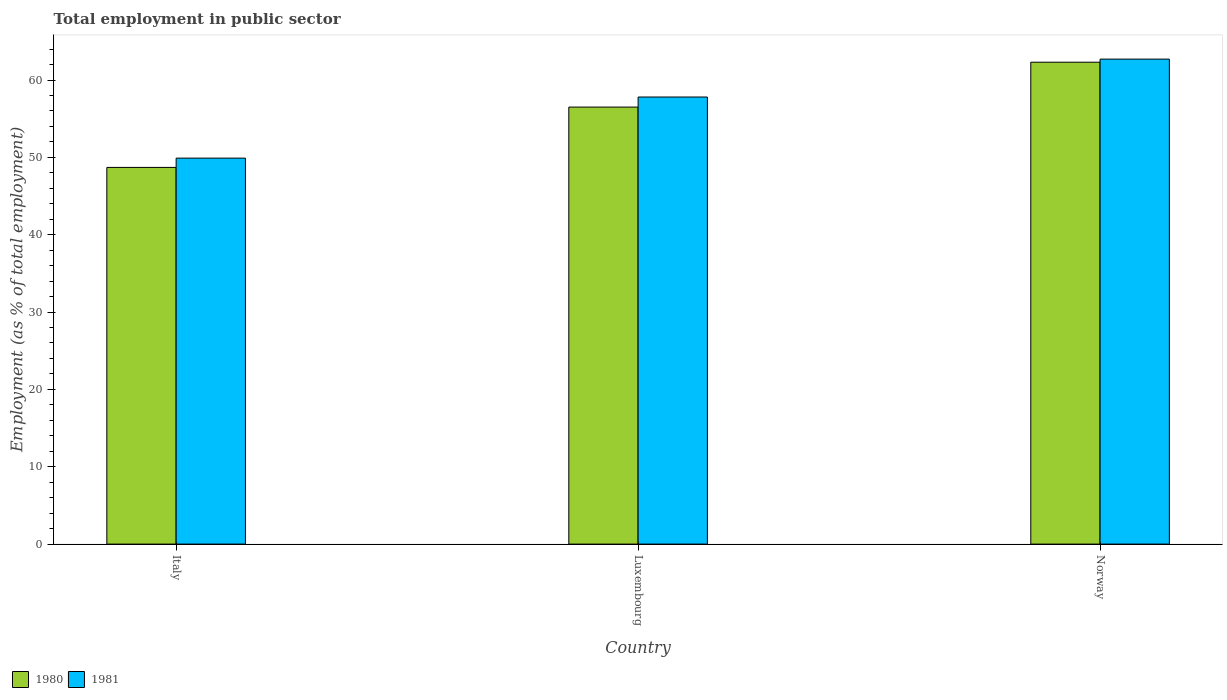How many different coloured bars are there?
Your answer should be compact. 2. How many groups of bars are there?
Ensure brevity in your answer.  3. How many bars are there on the 2nd tick from the left?
Offer a terse response. 2. In how many cases, is the number of bars for a given country not equal to the number of legend labels?
Give a very brief answer. 0. What is the employment in public sector in 1980 in Norway?
Ensure brevity in your answer.  62.3. Across all countries, what is the maximum employment in public sector in 1980?
Your response must be concise. 62.3. Across all countries, what is the minimum employment in public sector in 1981?
Your response must be concise. 49.9. In which country was the employment in public sector in 1980 maximum?
Provide a short and direct response. Norway. What is the total employment in public sector in 1981 in the graph?
Your answer should be compact. 170.4. What is the difference between the employment in public sector in 1981 in Italy and that in Luxembourg?
Give a very brief answer. -7.9. What is the average employment in public sector in 1980 per country?
Your answer should be compact. 55.83. What is the difference between the employment in public sector of/in 1981 and employment in public sector of/in 1980 in Norway?
Ensure brevity in your answer.  0.4. What is the ratio of the employment in public sector in 1980 in Italy to that in Luxembourg?
Give a very brief answer. 0.86. Is the employment in public sector in 1980 in Italy less than that in Luxembourg?
Ensure brevity in your answer.  Yes. Is the difference between the employment in public sector in 1981 in Italy and Norway greater than the difference between the employment in public sector in 1980 in Italy and Norway?
Offer a terse response. Yes. What is the difference between the highest and the second highest employment in public sector in 1980?
Make the answer very short. 7.8. What is the difference between the highest and the lowest employment in public sector in 1980?
Provide a short and direct response. 13.6. Is the sum of the employment in public sector in 1980 in Luxembourg and Norway greater than the maximum employment in public sector in 1981 across all countries?
Provide a succinct answer. Yes. What does the 2nd bar from the left in Italy represents?
Provide a succinct answer. 1981. What does the 2nd bar from the right in Luxembourg represents?
Offer a terse response. 1980. What is the difference between two consecutive major ticks on the Y-axis?
Keep it short and to the point. 10. Does the graph contain grids?
Keep it short and to the point. No. How are the legend labels stacked?
Offer a very short reply. Horizontal. What is the title of the graph?
Your response must be concise. Total employment in public sector. What is the label or title of the X-axis?
Provide a short and direct response. Country. What is the label or title of the Y-axis?
Offer a terse response. Employment (as % of total employment). What is the Employment (as % of total employment) of 1980 in Italy?
Keep it short and to the point. 48.7. What is the Employment (as % of total employment) in 1981 in Italy?
Offer a terse response. 49.9. What is the Employment (as % of total employment) in 1980 in Luxembourg?
Offer a terse response. 56.5. What is the Employment (as % of total employment) of 1981 in Luxembourg?
Your answer should be very brief. 57.8. What is the Employment (as % of total employment) in 1980 in Norway?
Provide a short and direct response. 62.3. What is the Employment (as % of total employment) of 1981 in Norway?
Your response must be concise. 62.7. Across all countries, what is the maximum Employment (as % of total employment) in 1980?
Your response must be concise. 62.3. Across all countries, what is the maximum Employment (as % of total employment) in 1981?
Your response must be concise. 62.7. Across all countries, what is the minimum Employment (as % of total employment) of 1980?
Provide a succinct answer. 48.7. Across all countries, what is the minimum Employment (as % of total employment) of 1981?
Give a very brief answer. 49.9. What is the total Employment (as % of total employment) in 1980 in the graph?
Your answer should be very brief. 167.5. What is the total Employment (as % of total employment) in 1981 in the graph?
Offer a terse response. 170.4. What is the difference between the Employment (as % of total employment) in 1980 in Italy and that in Luxembourg?
Give a very brief answer. -7.8. What is the difference between the Employment (as % of total employment) of 1981 in Italy and that in Luxembourg?
Your answer should be compact. -7.9. What is the difference between the Employment (as % of total employment) of 1980 in Luxembourg and that in Norway?
Offer a very short reply. -5.8. What is the difference between the Employment (as % of total employment) of 1981 in Luxembourg and that in Norway?
Offer a very short reply. -4.9. What is the difference between the Employment (as % of total employment) in 1980 in Italy and the Employment (as % of total employment) in 1981 in Luxembourg?
Provide a short and direct response. -9.1. What is the difference between the Employment (as % of total employment) of 1980 in Luxembourg and the Employment (as % of total employment) of 1981 in Norway?
Your answer should be compact. -6.2. What is the average Employment (as % of total employment) of 1980 per country?
Keep it short and to the point. 55.83. What is the average Employment (as % of total employment) in 1981 per country?
Provide a succinct answer. 56.8. What is the difference between the Employment (as % of total employment) in 1980 and Employment (as % of total employment) in 1981 in Luxembourg?
Keep it short and to the point. -1.3. What is the difference between the Employment (as % of total employment) of 1980 and Employment (as % of total employment) of 1981 in Norway?
Give a very brief answer. -0.4. What is the ratio of the Employment (as % of total employment) of 1980 in Italy to that in Luxembourg?
Keep it short and to the point. 0.86. What is the ratio of the Employment (as % of total employment) of 1981 in Italy to that in Luxembourg?
Provide a succinct answer. 0.86. What is the ratio of the Employment (as % of total employment) of 1980 in Italy to that in Norway?
Make the answer very short. 0.78. What is the ratio of the Employment (as % of total employment) in 1981 in Italy to that in Norway?
Keep it short and to the point. 0.8. What is the ratio of the Employment (as % of total employment) in 1980 in Luxembourg to that in Norway?
Offer a terse response. 0.91. What is the ratio of the Employment (as % of total employment) in 1981 in Luxembourg to that in Norway?
Offer a very short reply. 0.92. What is the difference between the highest and the second highest Employment (as % of total employment) in 1980?
Make the answer very short. 5.8. What is the difference between the highest and the second highest Employment (as % of total employment) of 1981?
Your answer should be very brief. 4.9. What is the difference between the highest and the lowest Employment (as % of total employment) in 1980?
Provide a succinct answer. 13.6. What is the difference between the highest and the lowest Employment (as % of total employment) of 1981?
Offer a very short reply. 12.8. 